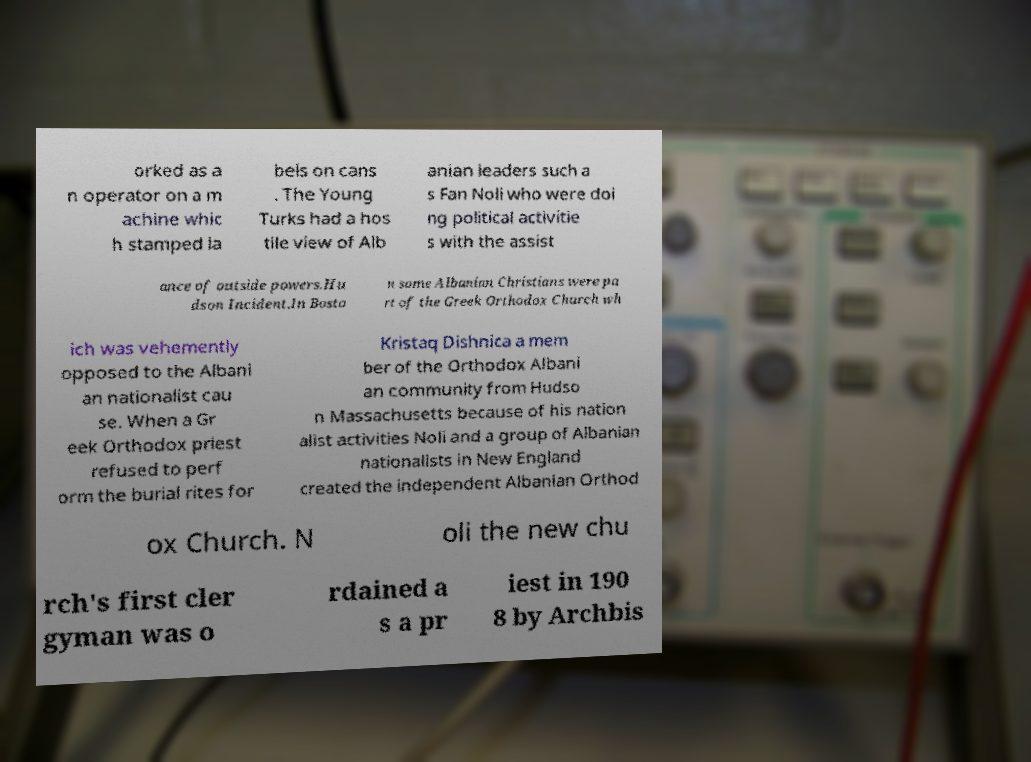What messages or text are displayed in this image? I need them in a readable, typed format. orked as a n operator on a m achine whic h stamped la bels on cans . The Young Turks had a hos tile view of Alb anian leaders such a s Fan Noli who were doi ng political activitie s with the assist ance of outside powers.Hu dson Incident.In Bosto n some Albanian Christians were pa rt of the Greek Orthodox Church wh ich was vehemently opposed to the Albani an nationalist cau se. When a Gr eek Orthodox priest refused to perf orm the burial rites for Kristaq Dishnica a mem ber of the Orthodox Albani an community from Hudso n Massachusetts because of his nation alist activities Noli and a group of Albanian nationalists in New England created the independent Albanian Orthod ox Church. N oli the new chu rch's first cler gyman was o rdained a s a pr iest in 190 8 by Archbis 